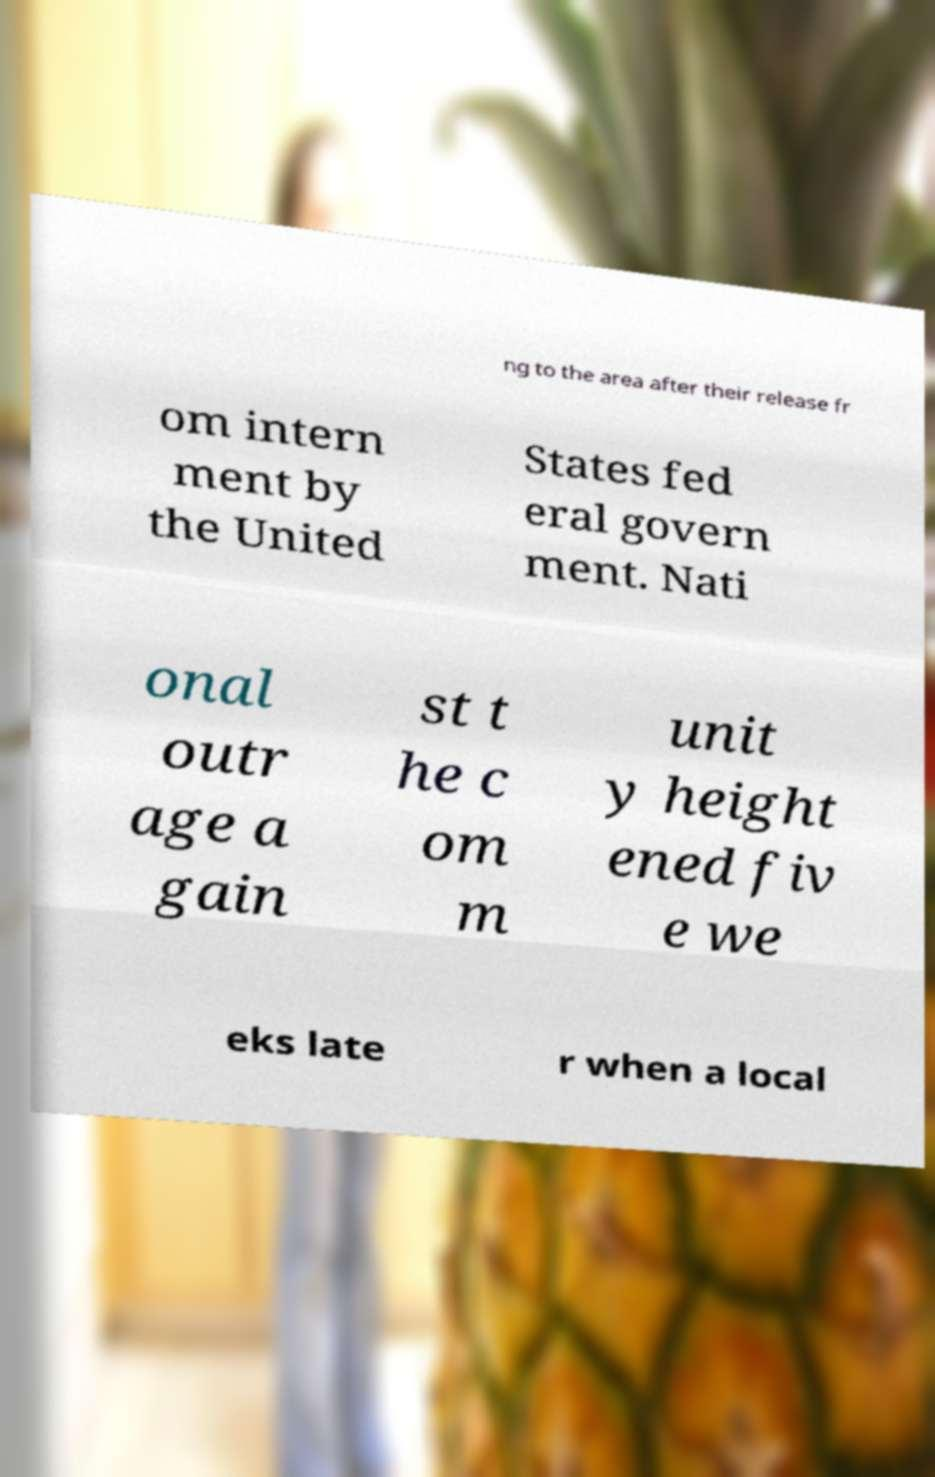Can you read and provide the text displayed in the image?This photo seems to have some interesting text. Can you extract and type it out for me? ng to the area after their release fr om intern ment by the United States fed eral govern ment. Nati onal outr age a gain st t he c om m unit y height ened fiv e we eks late r when a local 